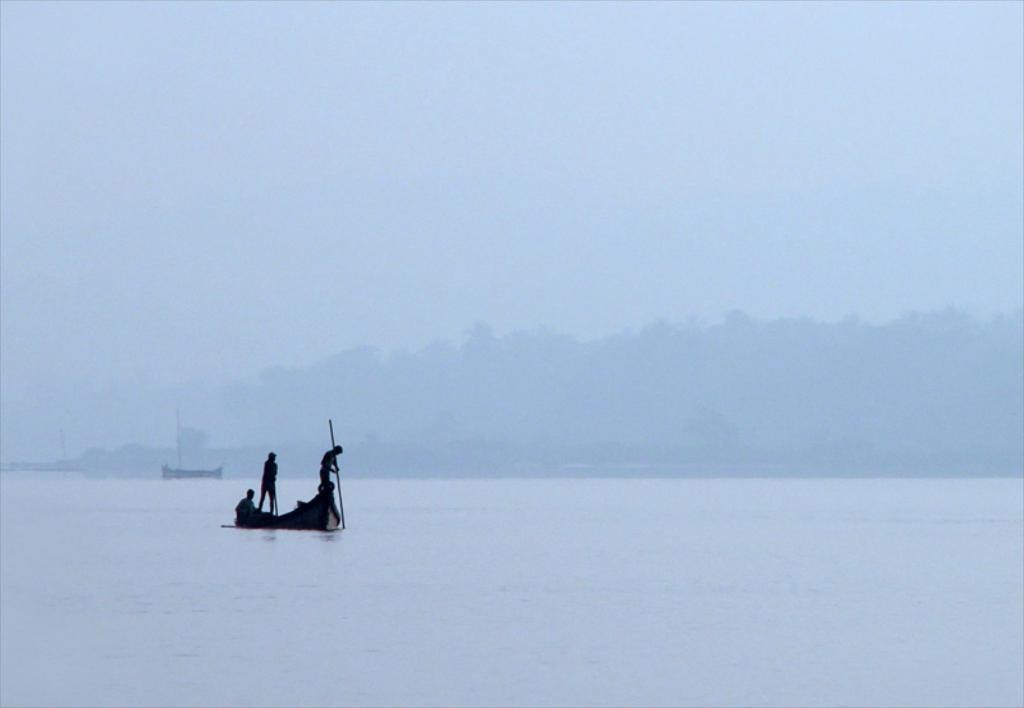What is the main element in the image? There is water in the image. What is located in the water? There is a boat in the water. Are there any people on the boat? Yes, there are people on the boat. How many bricks can be seen floating in the water? There are no bricks visible in the image; it features water, a boat, and people on the boat. What type of frogs are swimming alongside the boat? There are no frogs present in the image. 